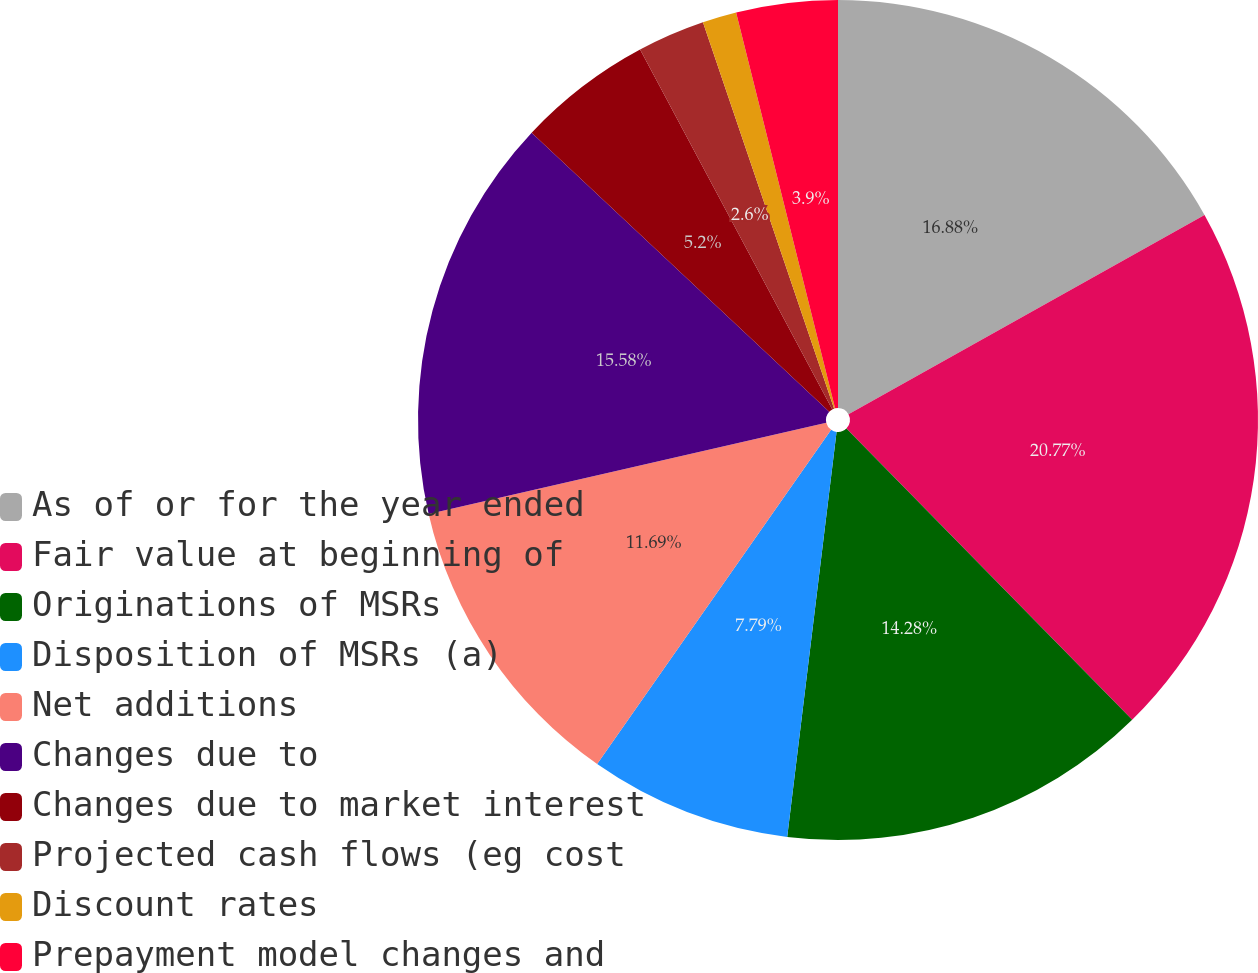<chart> <loc_0><loc_0><loc_500><loc_500><pie_chart><fcel>As of or for the year ended<fcel>Fair value at beginning of<fcel>Originations of MSRs<fcel>Disposition of MSRs (a)<fcel>Net additions<fcel>Changes due to<fcel>Changes due to market interest<fcel>Projected cash flows (eg cost<fcel>Discount rates<fcel>Prepayment model changes and<nl><fcel>16.88%<fcel>20.77%<fcel>14.28%<fcel>7.79%<fcel>11.69%<fcel>15.58%<fcel>5.2%<fcel>2.6%<fcel>1.31%<fcel>3.9%<nl></chart> 